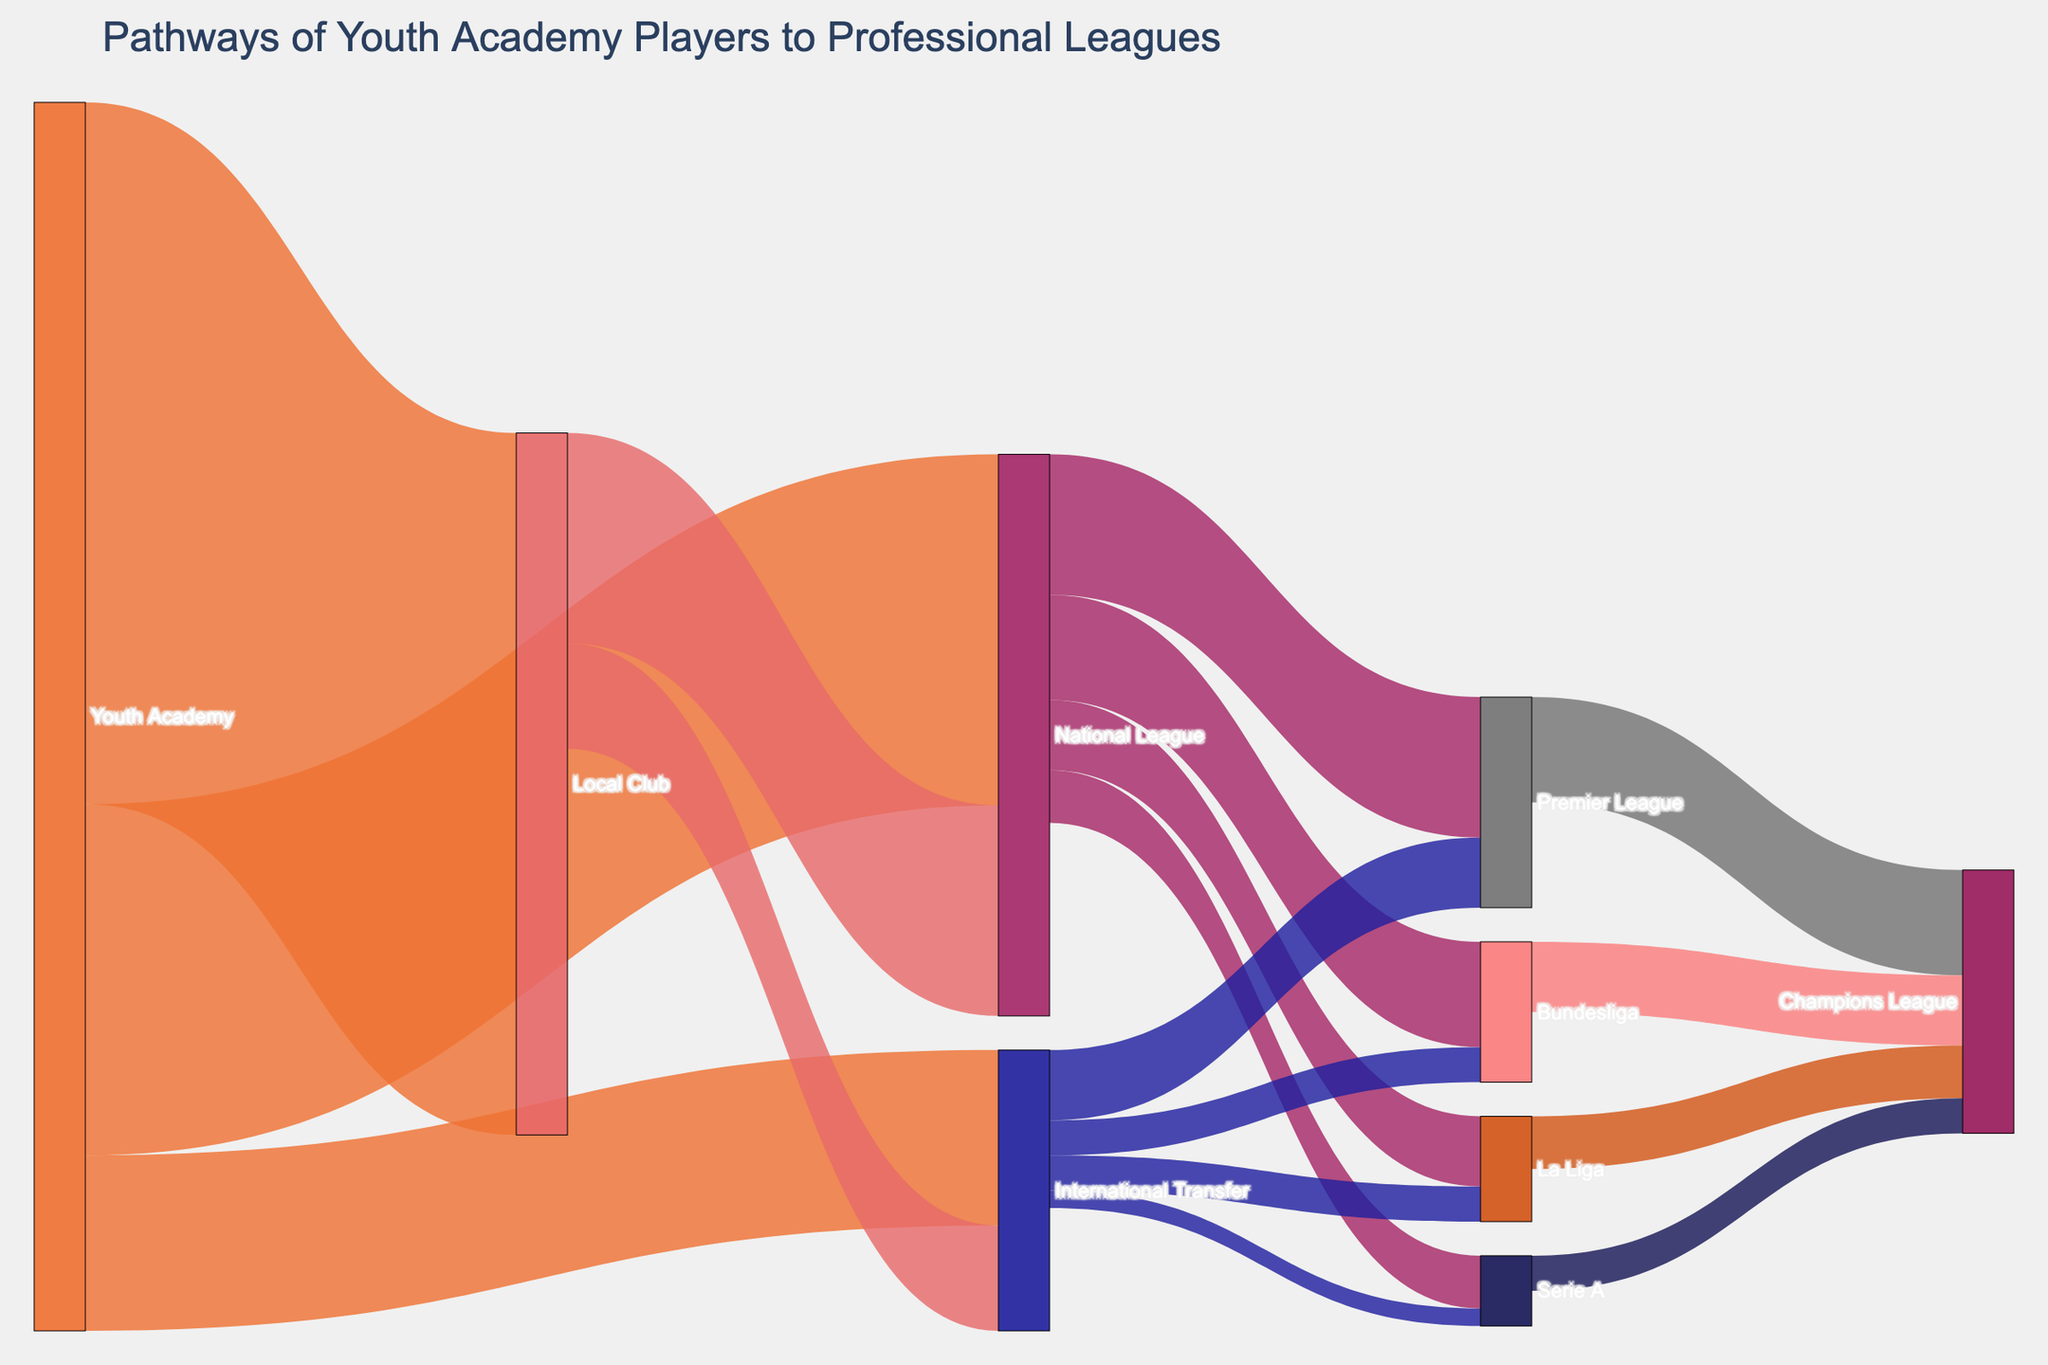What is the title of the figure? The title of the figure is located at the top. It indicates what the Sankey Diagram represents.
Answer: Pathways of Youth Academy Players to Professional Leagues How many youth academy players move directly to international transfers? Look at the Sankey path from 'Youth Academy' to 'International Transfer'.
Answer: 250 Which league receives the highest number of players from the National League? Identify the league target nodes from the National League and compare the values.
Answer: Premier League How many players transfer from local clubs to international leagues? Sum all the values moving from 'Local Club' to various international leagues.
Answer: 150 How many total players reach the Champions League? Sum the values of all paths leading to 'Champions League'. This includes paths from Premier League, Bundesliga, La Liga, and Serie A.
Answer: 375 Which pathway has the smallest value, and what is it? Look for the path with the smallest value among all the pathways shown.
Answer: International Transfer to Serie A, 25 Compare the numbers of players going from the National League to Bundesliga and La Liga. Which one is higher? Check the values for paths from 'National League' to 'Bundesliga' and 'La Liga'. Compare the two values.
Answer: Bundesliga, 150 vs La Liga, 100 What is the most common initial destination for youth academy players? Identify which target node connected directly to 'Youth Academy' has the highest value.
Answer: Local Club How many players in total move from the Youth Academy to any other team or league? Add up all the values for paths originating from 'Youth Academy'.
Answer: 1750 What is the total number of players that move from national leagues to international top leagues like Premier League, Bundesliga, La Liga, and Serie A combined? Sum the values for all paths leading from 'National League' to Premier League, Bundesliga, La Liga, and Serie A.
Answer: 525 